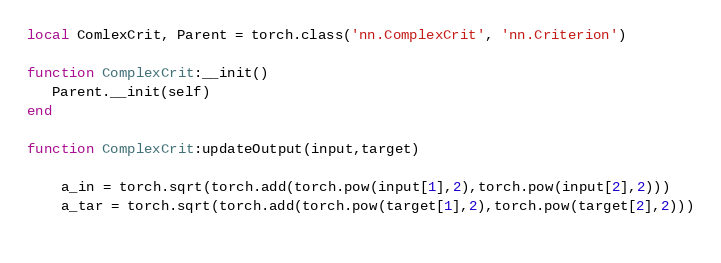Convert code to text. <code><loc_0><loc_0><loc_500><loc_500><_Lua_>local ComlexCrit, Parent = torch.class('nn.ComplexCrit', 'nn.Criterion')
 
function ComplexCrit:__init()
   Parent.__init(self)
end

function ComplexCrit:updateOutput(input,target)
    
    a_in = torch.sqrt(torch.add(torch.pow(input[1],2),torch.pow(input[2],2)))
    a_tar = torch.sqrt(torch.add(torch.pow(target[1],2),torch.pow(target[2],2)))
    </code> 